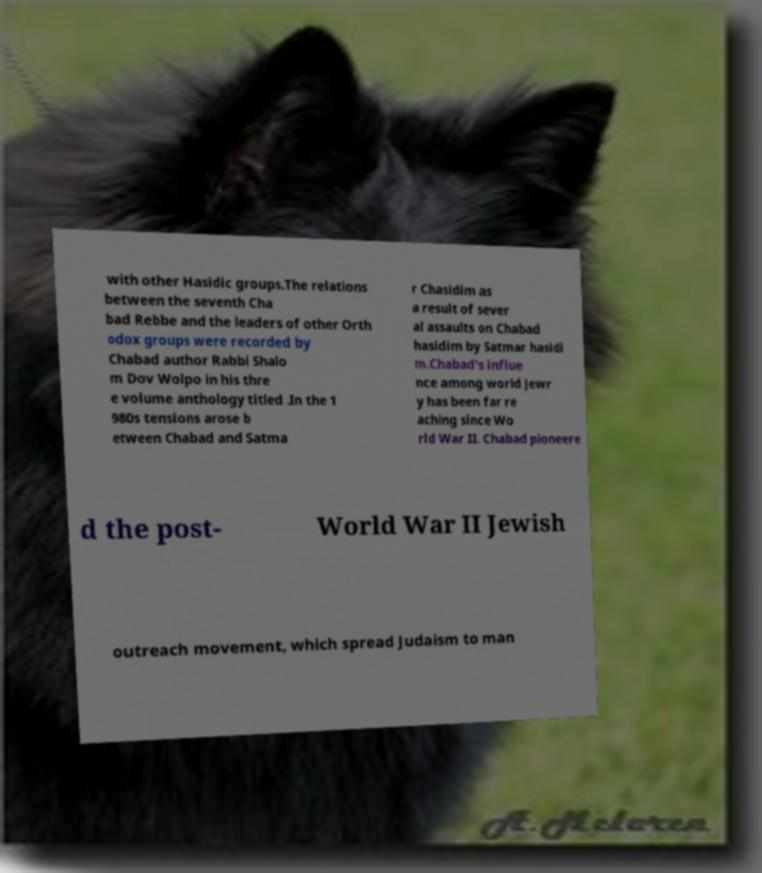Could you assist in decoding the text presented in this image and type it out clearly? with other Hasidic groups.The relations between the seventh Cha bad Rebbe and the leaders of other Orth odox groups were recorded by Chabad author Rabbi Shalo m Dov Wolpo in his thre e volume anthology titled .In the 1 980s tensions arose b etween Chabad and Satma r Chasidim as a result of sever al assaults on Chabad hasidim by Satmar hasidi m.Chabad's influe nce among world Jewr y has been far re aching since Wo rld War II. Chabad pioneere d the post- World War II Jewish outreach movement, which spread Judaism to man 